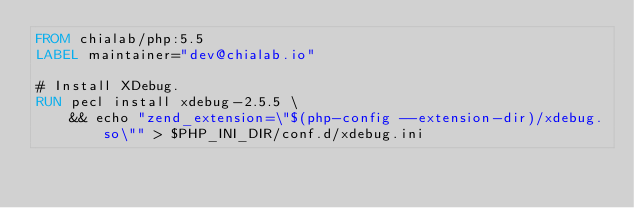<code> <loc_0><loc_0><loc_500><loc_500><_Dockerfile_>FROM chialab/php:5.5
LABEL maintainer="dev@chialab.io"

# Install XDebug.
RUN pecl install xdebug-2.5.5 \
    && echo "zend_extension=\"$(php-config --extension-dir)/xdebug.so\"" > $PHP_INI_DIR/conf.d/xdebug.ini
</code> 